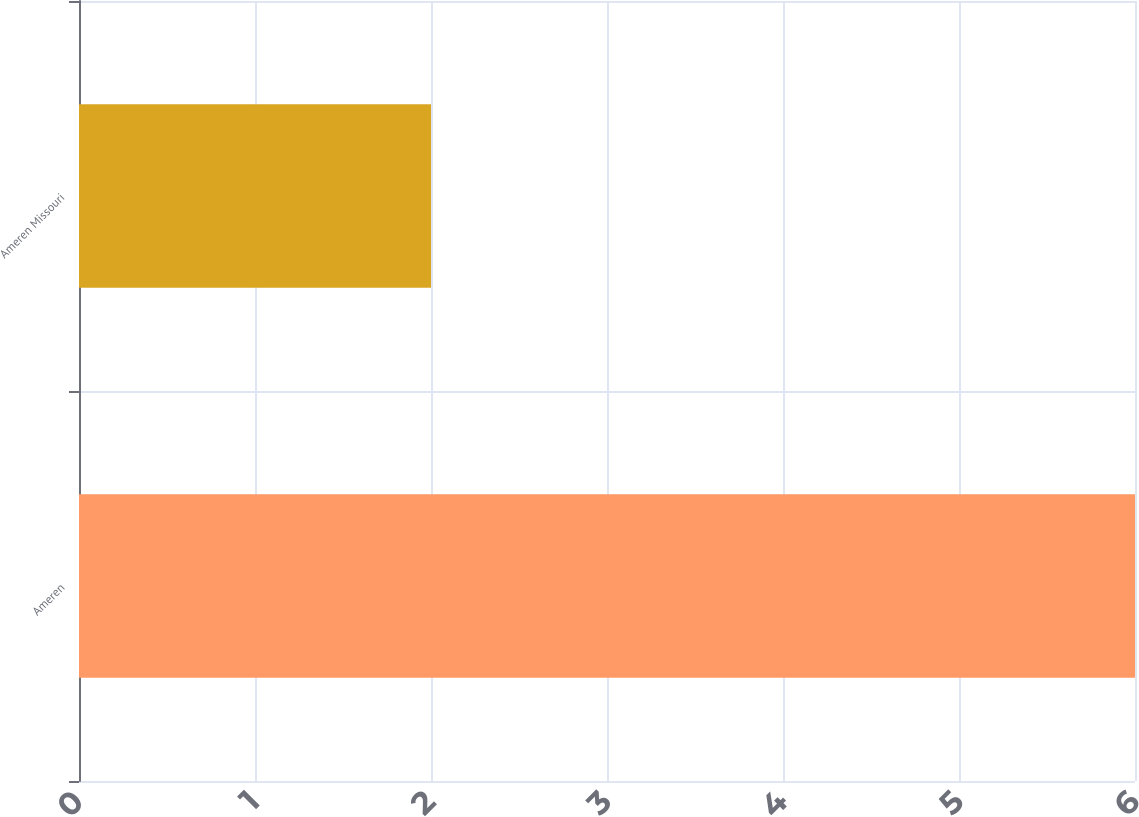Convert chart. <chart><loc_0><loc_0><loc_500><loc_500><bar_chart><fcel>Ameren<fcel>Ameren Missouri<nl><fcel>6<fcel>2<nl></chart> 